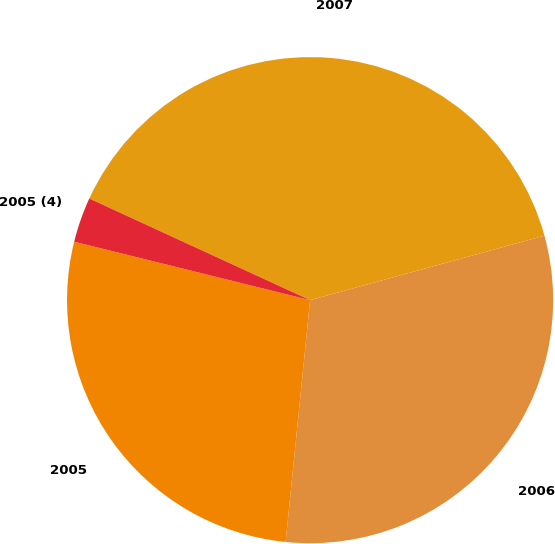Convert chart to OTSL. <chart><loc_0><loc_0><loc_500><loc_500><pie_chart><fcel>2007<fcel>2006<fcel>2005<fcel>2005 (4)<nl><fcel>38.86%<fcel>30.88%<fcel>27.26%<fcel>3.0%<nl></chart> 